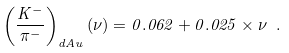Convert formula to latex. <formula><loc_0><loc_0><loc_500><loc_500>\left ( \frac { K ^ { - } } { \pi ^ { - } } \right ) _ { d A u } ( \nu ) = 0 . 0 6 2 + 0 . 0 2 5 \times \nu \ .</formula> 